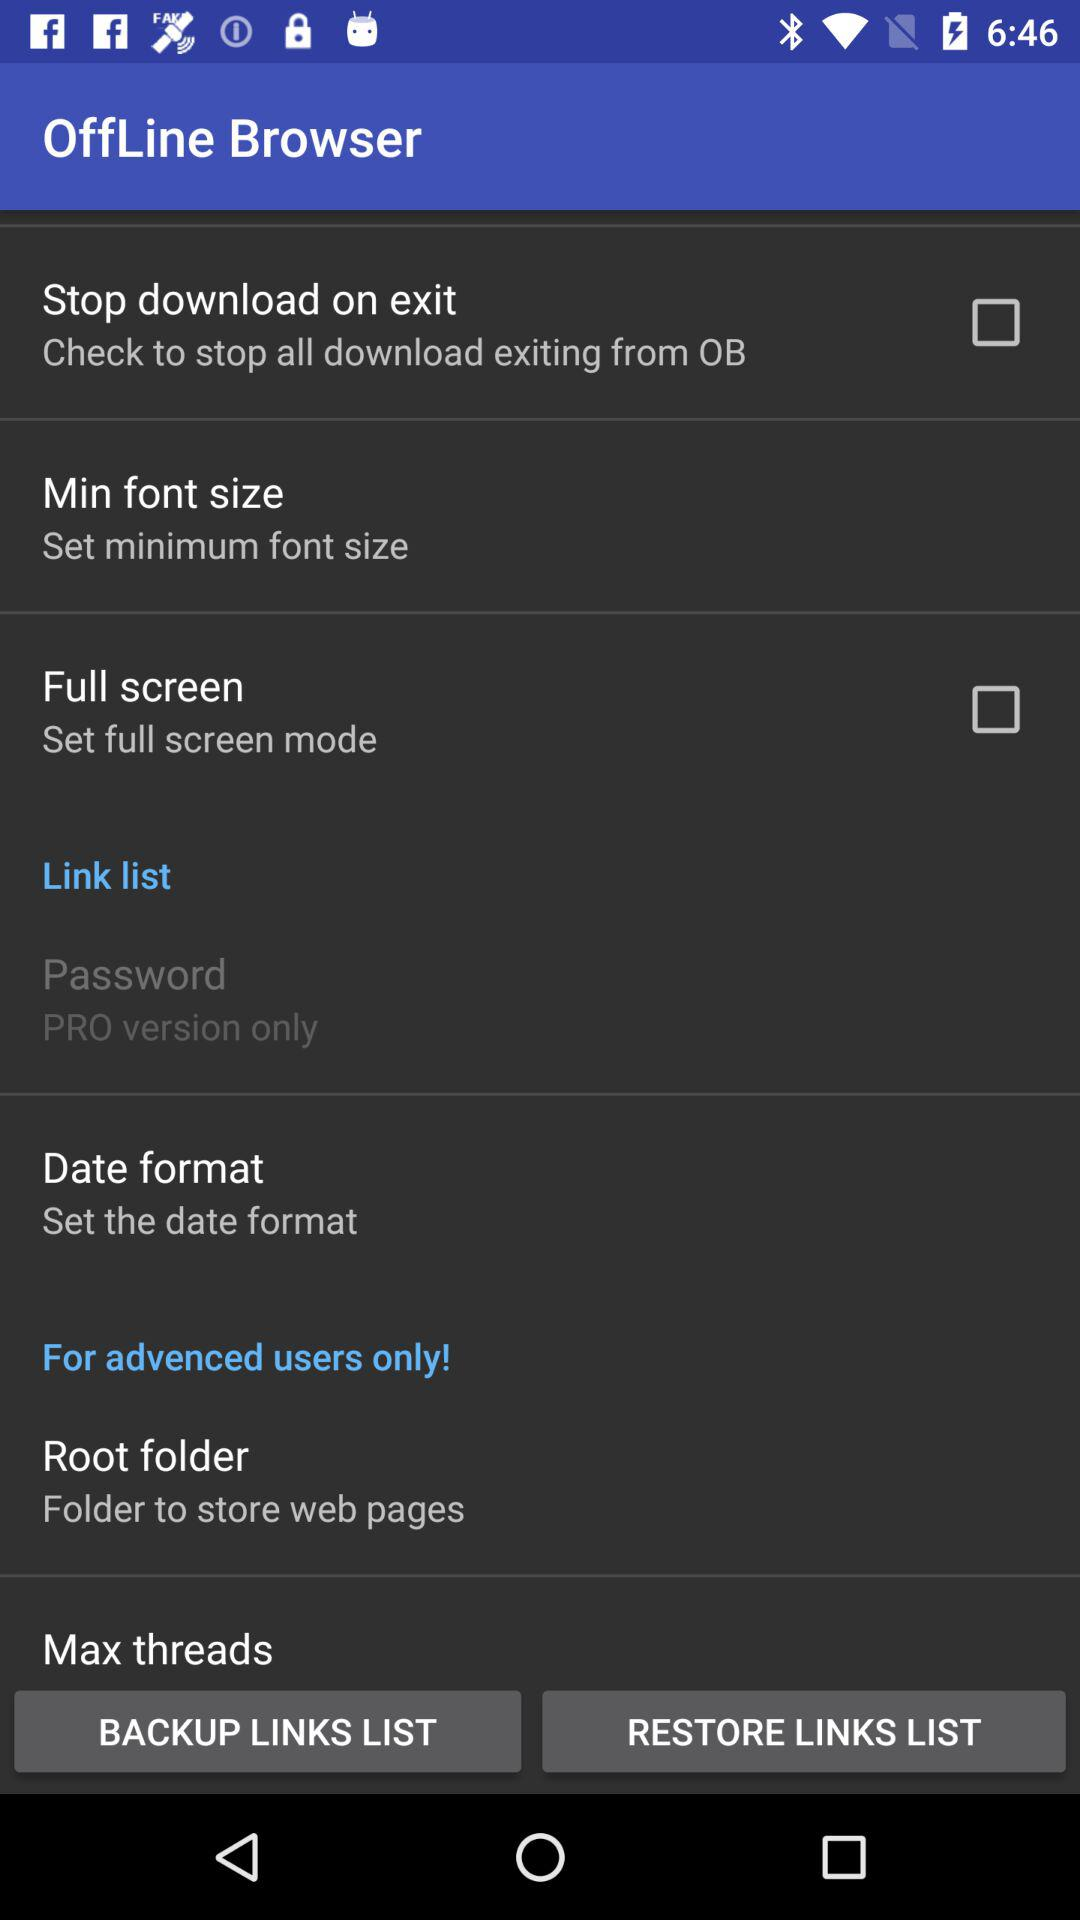What is the application name? The application name is "OffLine Browser". 